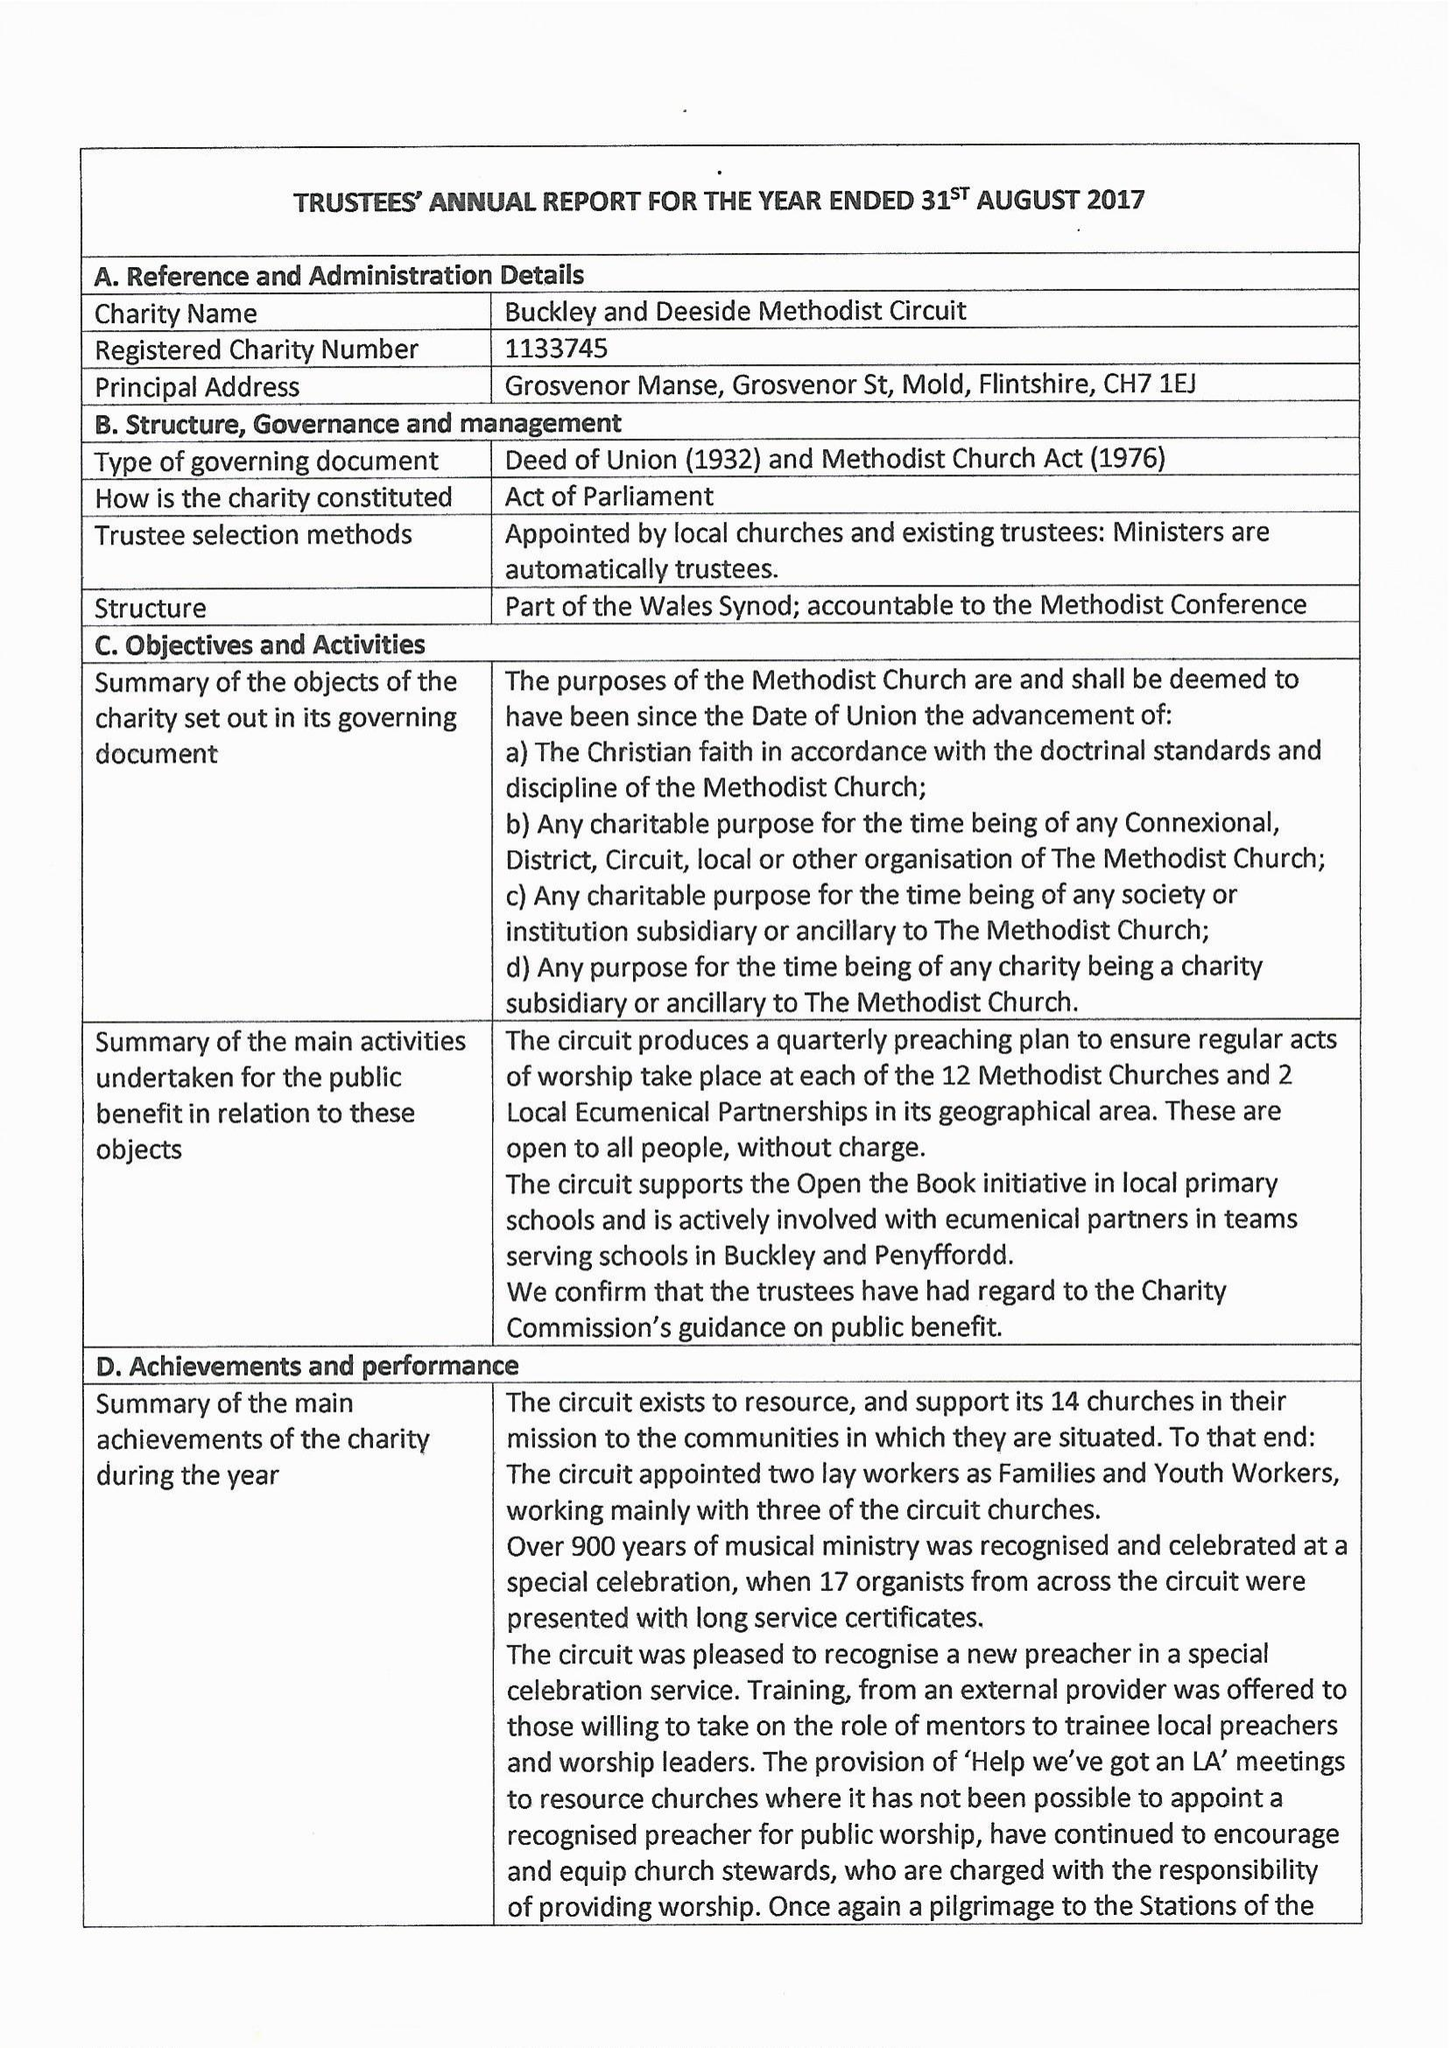What is the value for the report_date?
Answer the question using a single word or phrase. 2017-08-31 